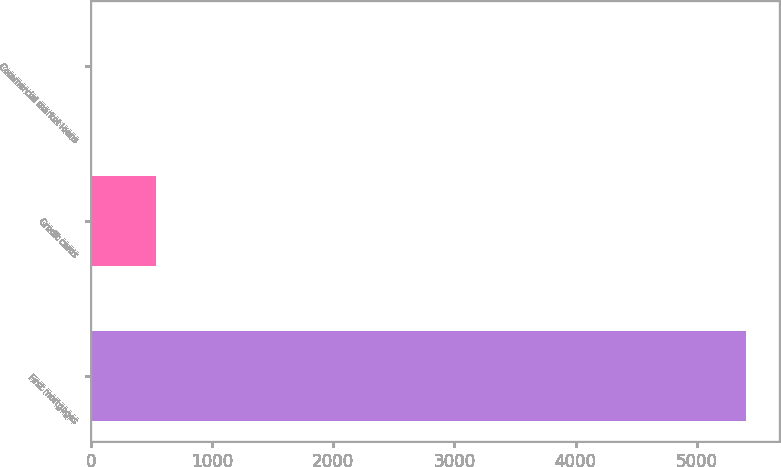Convert chart. <chart><loc_0><loc_0><loc_500><loc_500><bar_chart><fcel>First mortgages<fcel>Credit cards<fcel>Commercial market loans<nl><fcel>5405<fcel>541.4<fcel>1<nl></chart> 